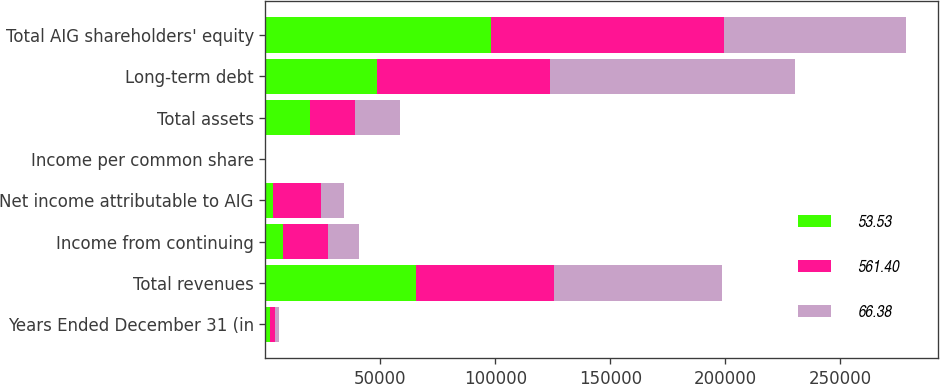Convert chart to OTSL. <chart><loc_0><loc_0><loc_500><loc_500><stacked_bar_chart><ecel><fcel>Years Ended December 31 (in<fcel>Total revenues<fcel>Income from continuing<fcel>Net income attributable to AIG<fcel>Income per common share<fcel>Total assets<fcel>Long-term debt<fcel>Total AIG shareholders' equity<nl><fcel>53.53<fcel>2012<fcel>65656<fcel>7752<fcel>3438<fcel>2.04<fcel>19540<fcel>48500<fcel>98002<nl><fcel>561.4<fcel>2011<fcel>59812<fcel>19540<fcel>20622<fcel>11.01<fcel>19540<fcel>75253<fcel>101538<nl><fcel>66.38<fcel>2010<fcel>72829<fcel>13254<fcel>10058<fcel>14.98<fcel>19540<fcel>106461<fcel>78856<nl></chart> 